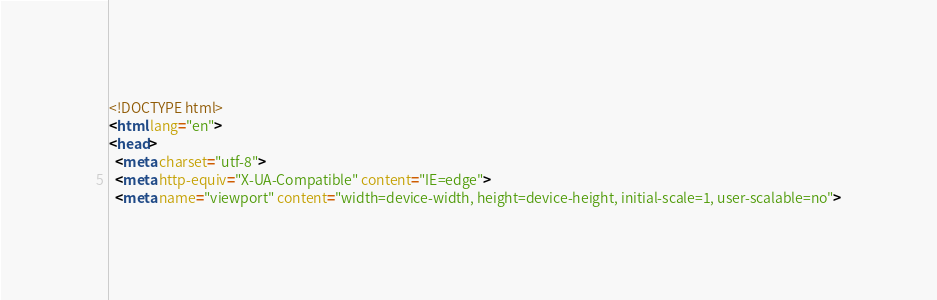<code> <loc_0><loc_0><loc_500><loc_500><_HTML_><!DOCTYPE html>
<html lang="en">
<head>
  <meta charset="utf-8">
  <meta http-equiv="X-UA-Compatible" content="IE=edge">
  <meta name="viewport" content="width=device-width, height=device-height, initial-scale=1, user-scalable=no"></code> 